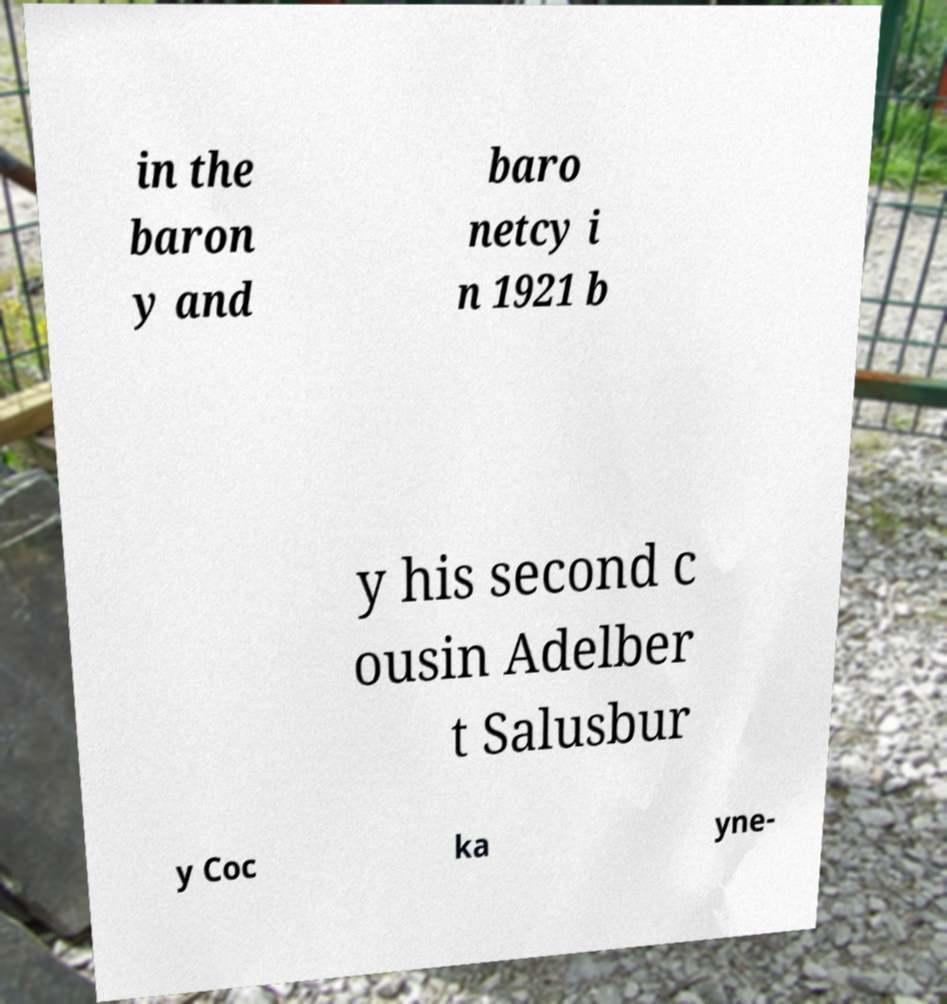I need the written content from this picture converted into text. Can you do that? in the baron y and baro netcy i n 1921 b y his second c ousin Adelber t Salusbur y Coc ka yne- 